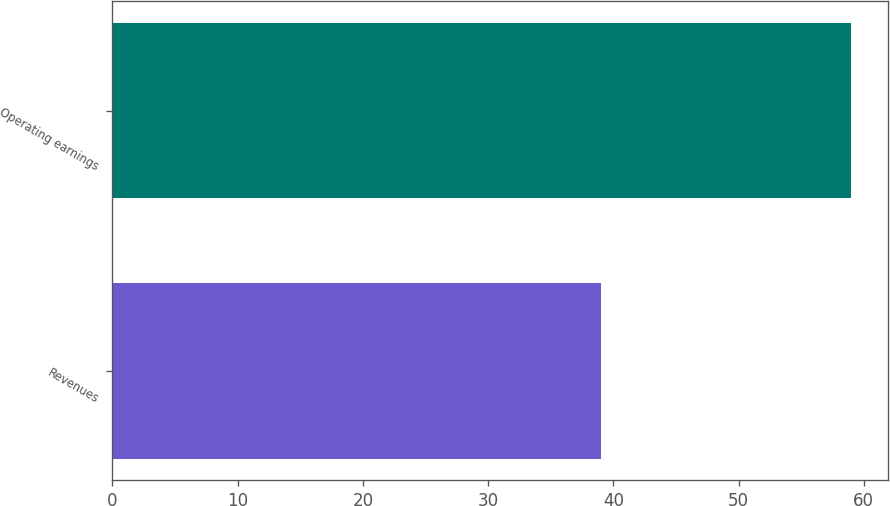Convert chart. <chart><loc_0><loc_0><loc_500><loc_500><bar_chart><fcel>Revenues<fcel>Operating earnings<nl><fcel>39<fcel>59<nl></chart> 